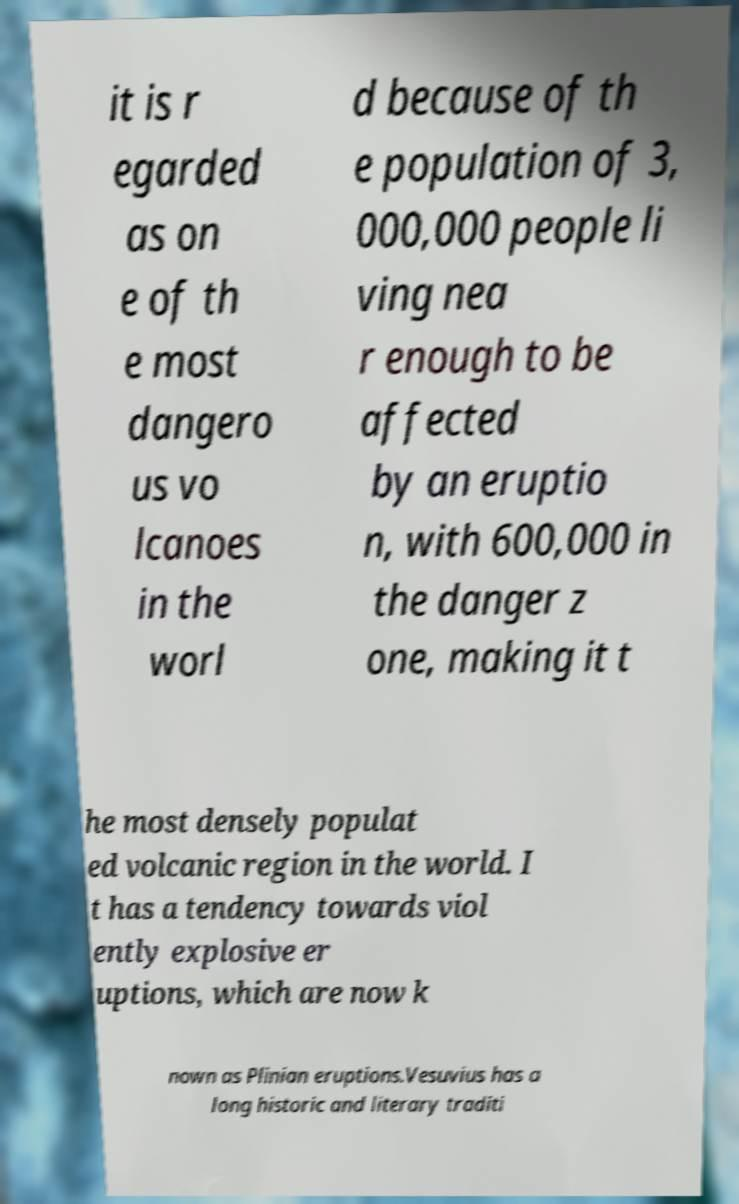Could you assist in decoding the text presented in this image and type it out clearly? it is r egarded as on e of th e most dangero us vo lcanoes in the worl d because of th e population of 3, 000,000 people li ving nea r enough to be affected by an eruptio n, with 600,000 in the danger z one, making it t he most densely populat ed volcanic region in the world. I t has a tendency towards viol ently explosive er uptions, which are now k nown as Plinian eruptions.Vesuvius has a long historic and literary traditi 